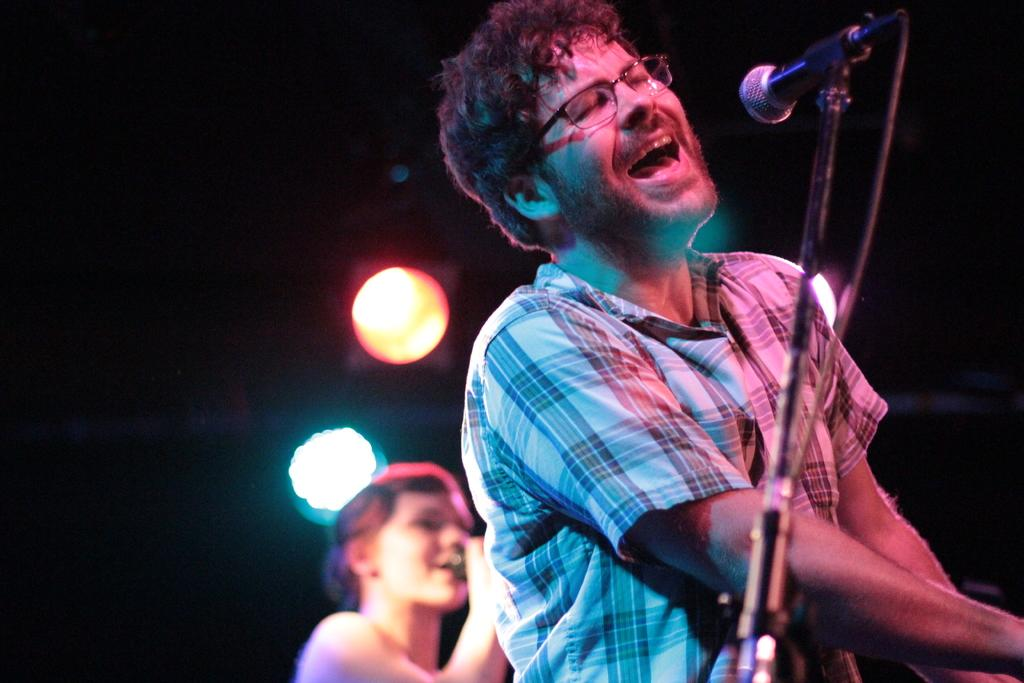What is the man in the image doing? The man is singing in the image. What is the man holding while singing? The man is holding a microphone. Can you describe the man's attire in the image? The man is wearing a shirt and spectacles. Who else is present in the image? There is a woman in the image. What is the woman doing? The woman is singing in the image. What can be seen in the background that might be related to the performance? There are focus lights in the image. What is the man's annual income in the image? There is no information about the man's income in the image. Can you tell me how many verses the woman is singing in the image? There is no indication of the number of verses being sung in the image. 